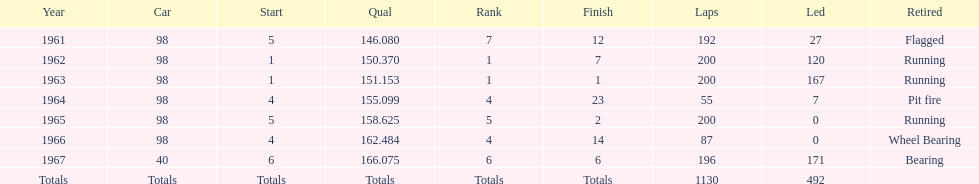What was his best finish before his first win? 7. 